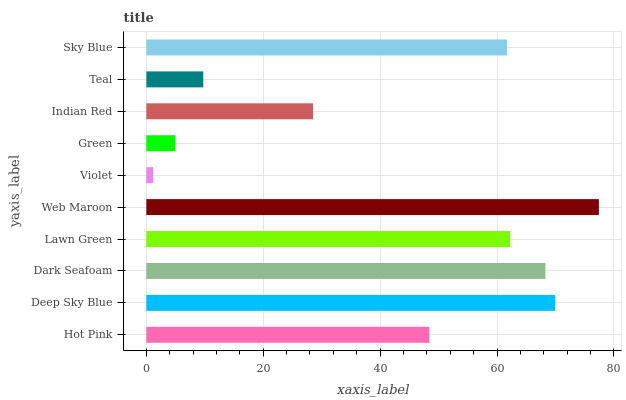Is Violet the minimum?
Answer yes or no. Yes. Is Web Maroon the maximum?
Answer yes or no. Yes. Is Deep Sky Blue the minimum?
Answer yes or no. No. Is Deep Sky Blue the maximum?
Answer yes or no. No. Is Deep Sky Blue greater than Hot Pink?
Answer yes or no. Yes. Is Hot Pink less than Deep Sky Blue?
Answer yes or no. Yes. Is Hot Pink greater than Deep Sky Blue?
Answer yes or no. No. Is Deep Sky Blue less than Hot Pink?
Answer yes or no. No. Is Sky Blue the high median?
Answer yes or no. Yes. Is Hot Pink the low median?
Answer yes or no. Yes. Is Dark Seafoam the high median?
Answer yes or no. No. Is Web Maroon the low median?
Answer yes or no. No. 